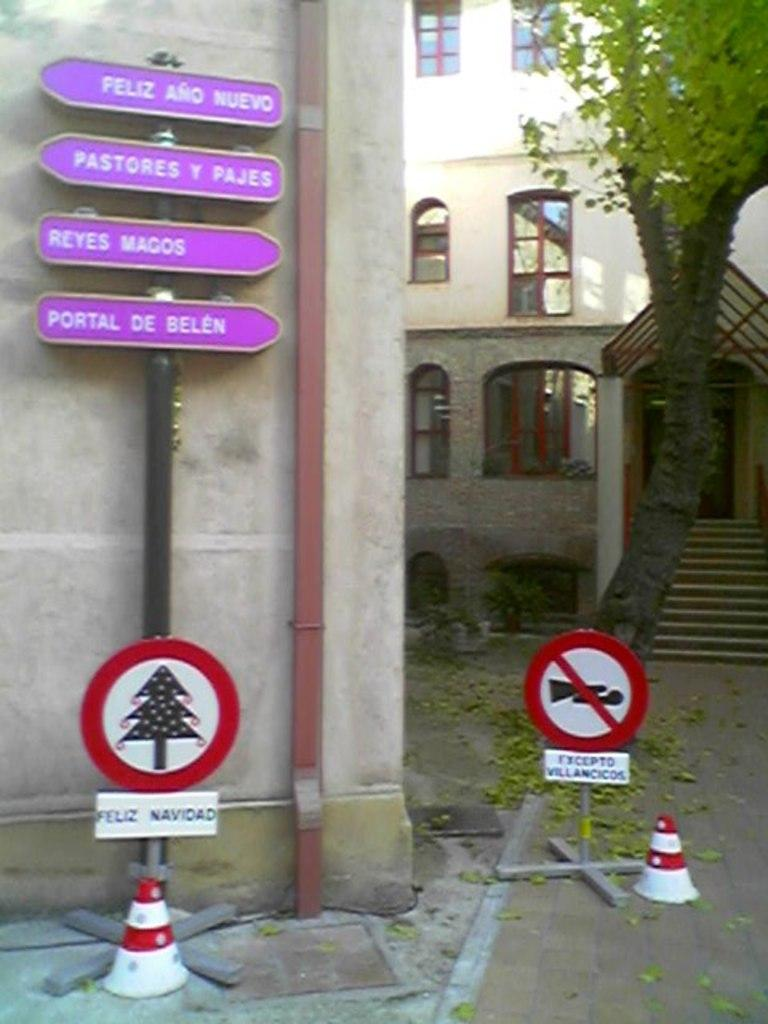<image>
Describe the image concisely. some signs with 1 that says Pastores on it 